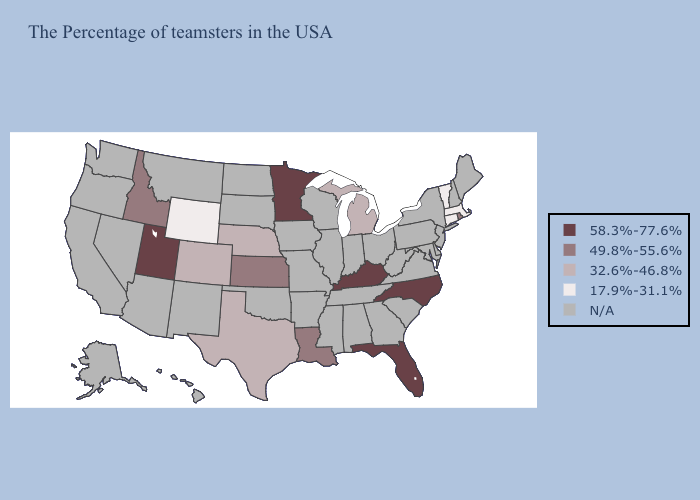Among the states that border Wyoming , does Utah have the highest value?
Give a very brief answer. Yes. Name the states that have a value in the range 58.3%-77.6%?
Answer briefly. North Carolina, Florida, Kentucky, Minnesota, Utah. Does the first symbol in the legend represent the smallest category?
Write a very short answer. No. Does Wyoming have the highest value in the USA?
Write a very short answer. No. Name the states that have a value in the range N/A?
Be succinct. Maine, New Hampshire, New York, New Jersey, Delaware, Maryland, Pennsylvania, Virginia, South Carolina, West Virginia, Ohio, Georgia, Indiana, Alabama, Tennessee, Wisconsin, Illinois, Mississippi, Missouri, Arkansas, Iowa, Oklahoma, South Dakota, North Dakota, New Mexico, Montana, Arizona, Nevada, California, Washington, Oregon, Alaska, Hawaii. Name the states that have a value in the range 17.9%-31.1%?
Write a very short answer. Massachusetts, Vermont, Connecticut, Wyoming. Name the states that have a value in the range 49.8%-55.6%?
Be succinct. Rhode Island, Louisiana, Kansas, Idaho. Name the states that have a value in the range 58.3%-77.6%?
Be succinct. North Carolina, Florida, Kentucky, Minnesota, Utah. Name the states that have a value in the range 17.9%-31.1%?
Give a very brief answer. Massachusetts, Vermont, Connecticut, Wyoming. What is the lowest value in the USA?
Keep it brief. 17.9%-31.1%. What is the value of Tennessee?
Give a very brief answer. N/A. 